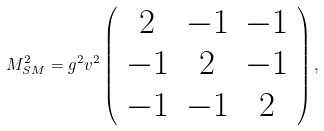Convert formula to latex. <formula><loc_0><loc_0><loc_500><loc_500>M _ { S M } ^ { 2 } = g ^ { 2 } v ^ { 2 } \left ( \begin{array} { c c c } { 2 } & { - 1 } & { - 1 } \\ { - 1 } & { 2 } & { - 1 } \\ { - 1 } & { - 1 } & { 2 } \end{array} \right ) , \,</formula> 